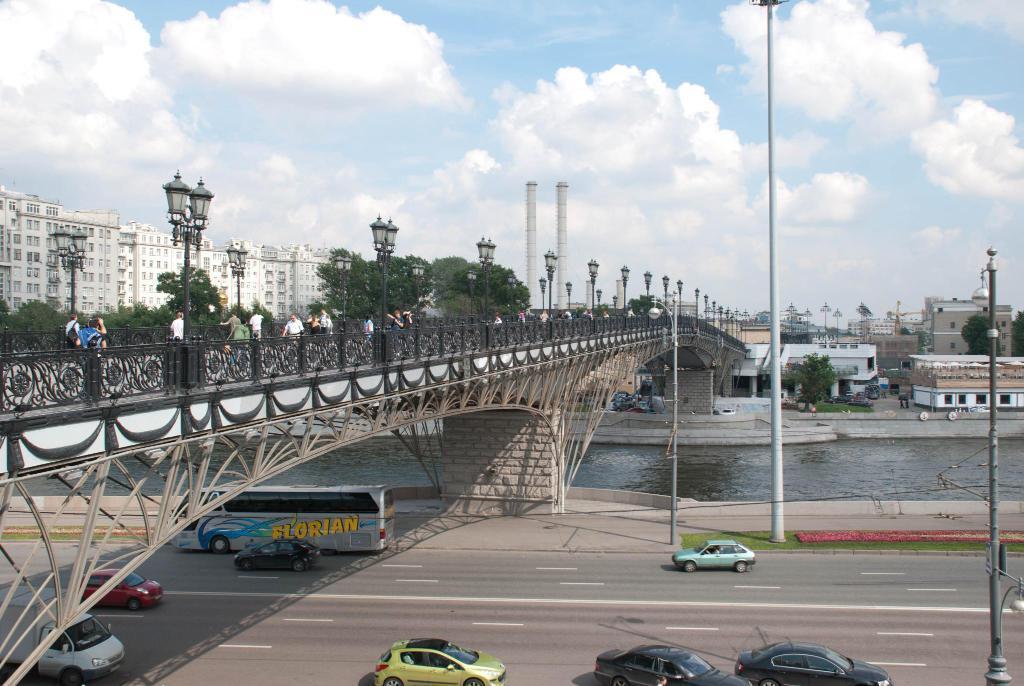Please provide a concise description of this image. In this image I can see people on the bridge. I can also see vehicles on the road. Here I can see water, street lights, water, buildings and other objects. In the background I can see the sky. 